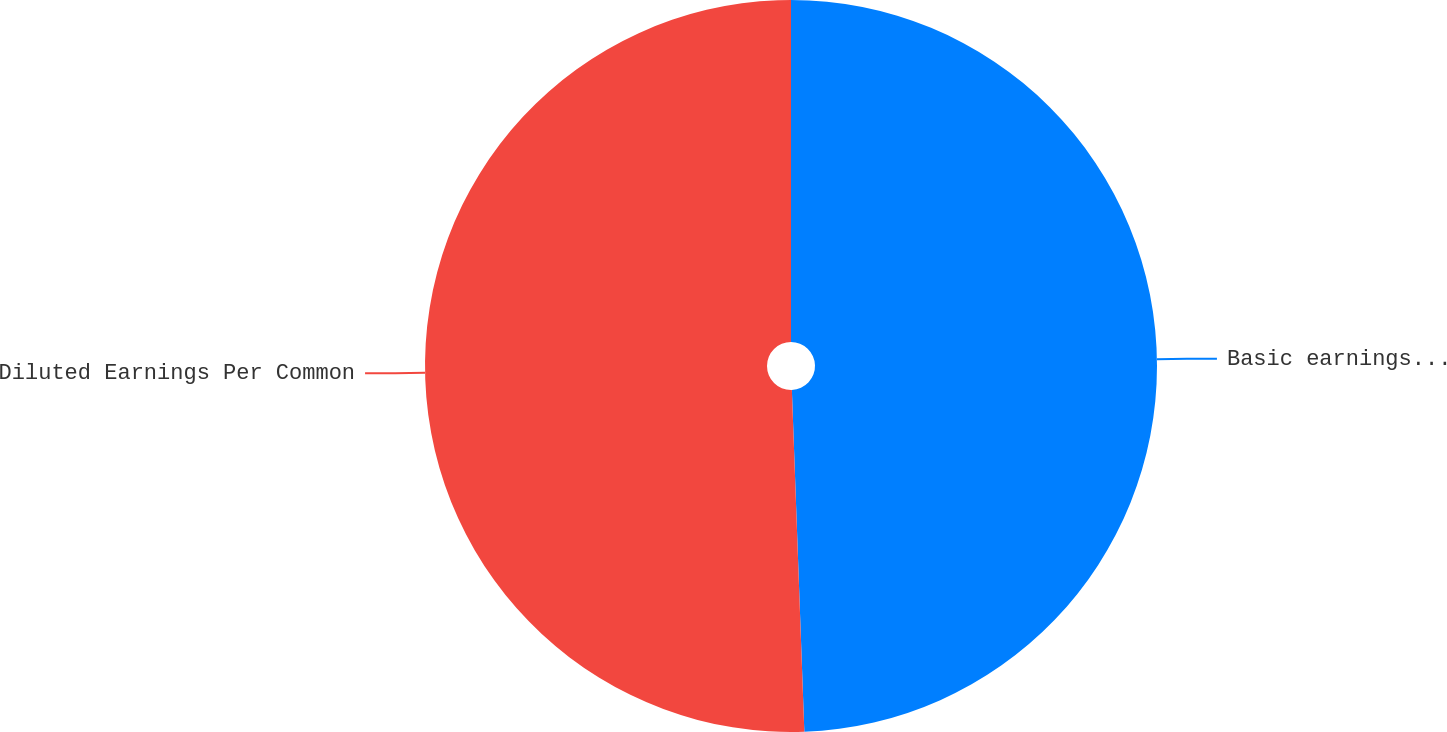Convert chart. <chart><loc_0><loc_0><loc_500><loc_500><pie_chart><fcel>Basic earnings per common<fcel>Diluted Earnings Per Common<nl><fcel>49.42%<fcel>50.58%<nl></chart> 